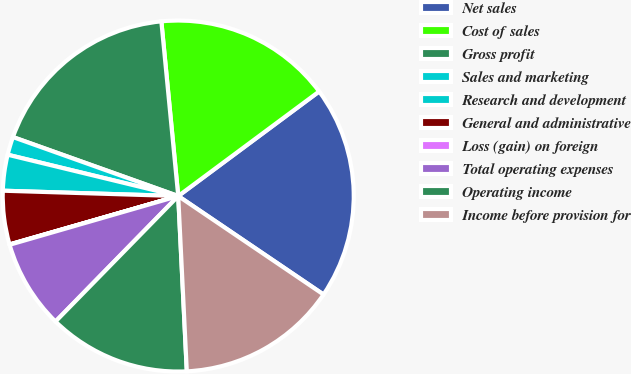<chart> <loc_0><loc_0><loc_500><loc_500><pie_chart><fcel>Net sales<fcel>Cost of sales<fcel>Gross profit<fcel>Sales and marketing<fcel>Research and development<fcel>General and administrative<fcel>Loss (gain) on foreign<fcel>Total operating expenses<fcel>Operating income<fcel>Income before provision for<nl><fcel>19.64%<fcel>16.37%<fcel>18.01%<fcel>1.67%<fcel>3.3%<fcel>4.93%<fcel>0.03%<fcel>8.2%<fcel>13.1%<fcel>14.74%<nl></chart> 